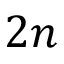<formula> <loc_0><loc_0><loc_500><loc_500>2 n</formula> 